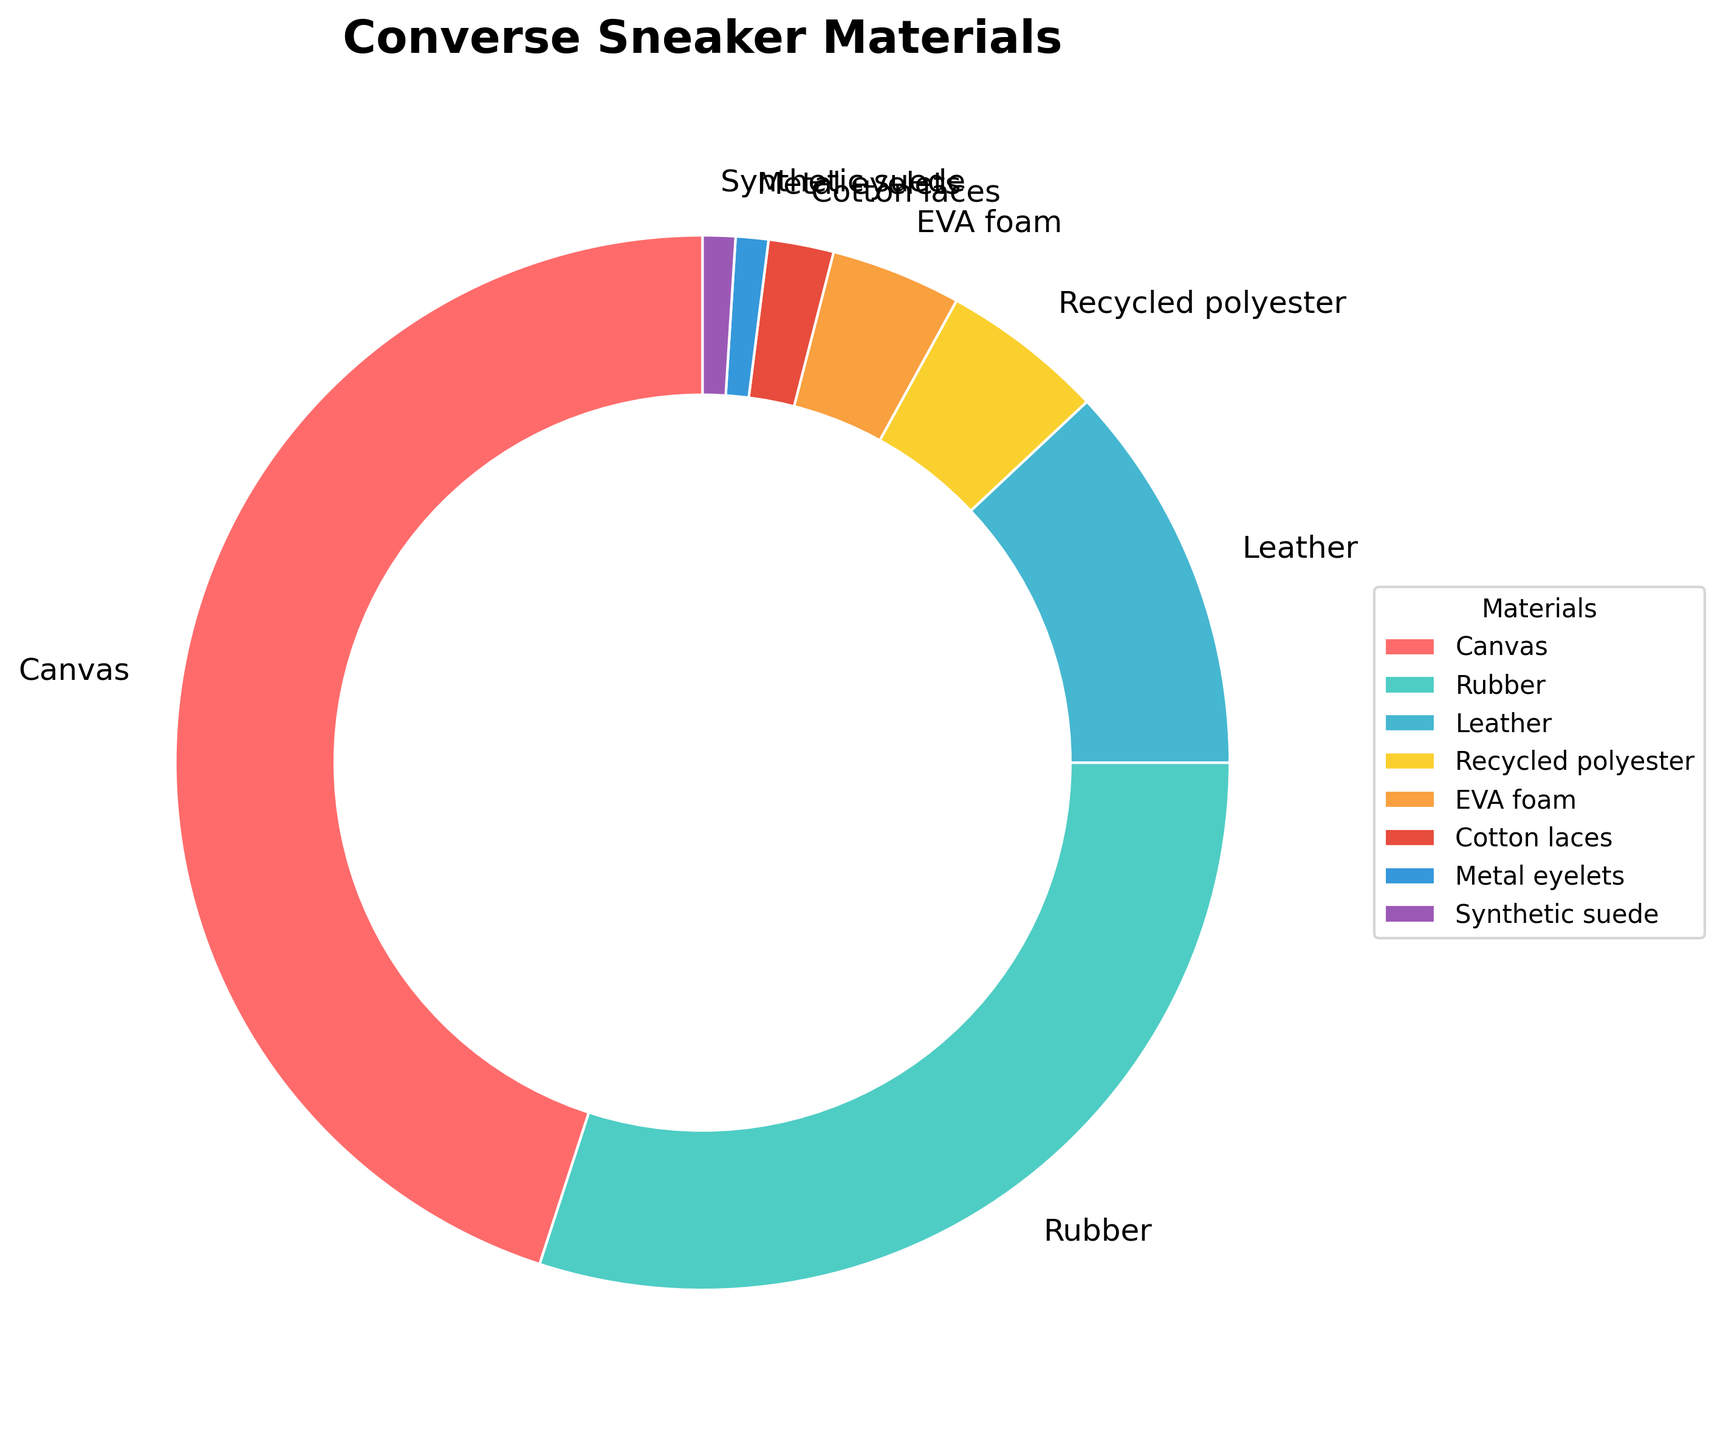What's the material with the highest percentage in Converse sneaker manufacturing? By looking at the chart, the largest wedge corresponds to Canvas, which has the highest percentage.
Answer: Canvas What percentage of materials used are non-textile (Rubber, EVA foam, Metal eyelets)? Sum the percentages of Rubber (30), EVA foam (4), and Metal eyelets (1): 30 + 4 + 1 = 35%
Answer: 35% Which material contributes more to Converse sneakers: Leather or Recycled polyester? The chart shows that Leather has 12% and Recycled polyester has 5%. Since 12% > 5%, Leather contributes more.
Answer: Leather What is the combined percentage of Canvas and Rubber in Converse sneakers? Sum the percentages of Canvas (45) and Rubber (30): 45 + 30 = 75%
Answer: 75% Among synthetic materials, which has the smallest percentage used in Converse sneakers? The synthetic materials are synthetic suede (1%), recycled polyester (5%), and EVA foam (4%). The smallest percentage is synthetic suede.
Answer: Synthetic suede Which category contributes more to the sneakers, Leather + Cotton laces or Rubber? Sum the percentages of Leather (12) and Cotton laces (2) and compare to Rubber (30): 12 + 2 = 14, which is less than 30. So, Rubber contributes more.
Answer: Rubber What is the ratio of Canvas to Leather in terms of percentage use? The percentages are 45% for Canvas and 12% for Leather. The ratio is 45:12, which simplifies to 15:4.
Answer: 15:4 How does the percentage of Cotton laces compare to Metal eyelets? Both Cotton laces and Metal eyelets have percentages displayed on the chart: Cotton laces (2%) and Metal eyelets (1%). Hence, Cotton laces have twice the percentage of Metal eyelets.
Answer: Cotton laces (2) to Metal eyelets (1) What percentage of the materials used is textile-based (Canvas, Leather, Cotton laces)? Sum the percentages of Canvas (45), Leather (12), and Cotton laces (2): 45 + 12 + 2 = 59%
Answer: 59% Does EVA foam make up less than 10% of the materials used? Looking at the chart, EVA foam has 4%, which is less than 10%.
Answer: Yes 